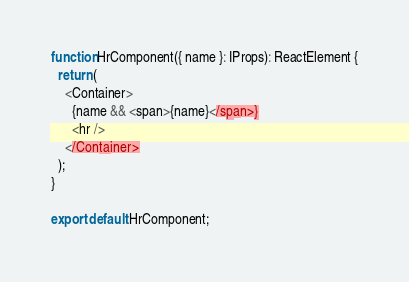Convert code to text. <code><loc_0><loc_0><loc_500><loc_500><_TypeScript_>
function HrComponent({ name }: IProps): ReactElement {
  return (
    <Container>
      {name && <span>{name}</span>}
      <hr />
    </Container>
  );
}

export default HrComponent;
</code> 